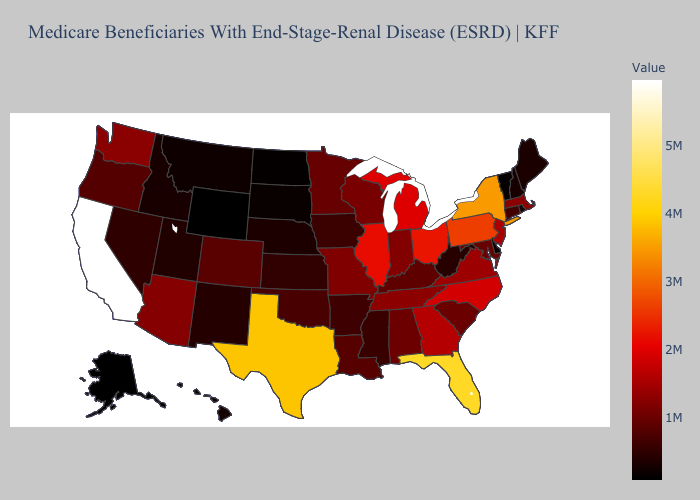Which states hav the highest value in the Northeast?
Quick response, please. New York. Does New York have the highest value in the Northeast?
Keep it brief. Yes. Which states have the lowest value in the USA?
Be succinct. Alaska. Does Arizona have the highest value in the West?
Concise answer only. No. Which states have the lowest value in the USA?
Write a very short answer. Alaska. Among the states that border Tennessee , does Alabama have the lowest value?
Quick response, please. No. Among the states that border Montana , which have the highest value?
Be succinct. Idaho. Does New York have the highest value in the USA?
Concise answer only. No. 